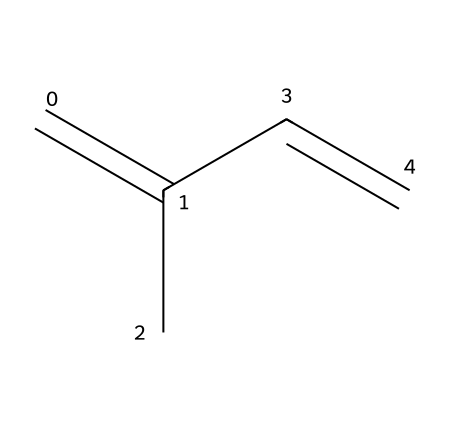How many carbon atoms are in isoprene? The SMILES representation shows four 'C' characters, indicating there are four carbon atoms in the structure.
Answer: four What type of bonds are present in isoprene? The structure indicates there are both single and double bonds, particularly noted by the presence of '=' which denotes double bonds between certain carbon atoms.
Answer: double and single bonds What geometric isomers can isoprene have? The structure can exhibit geometric isomerism due to the double bonds, which can lead to cis and trans configurations around those double bonds.
Answer: cis and trans How many hydrogen atoms are in the maximum stable isoprene structure? Given the four carbon atoms and the structure of isoprene (C4H6), the maximum number of hydrogen atoms in a stable structure is derived as 2n + 2, where n is the number of carbons; hence 2(4) + 2 = 10. However, with existing double bonds, the number is reduced to 6.
Answer: six What is the effect of the geometric isomers of isoprene in racing suit materials? The different geometric isomers can influence the physical properties, such as elasticity and durability, which are critical in racing suit materials.
Answer: property influence Which part of the structure determines its geometric isomerism? The presence of the double bond (indicated by the '=' symbol) is what allows for geometric isomerism due to the restricted rotation around the double bond.
Answer: double bond 